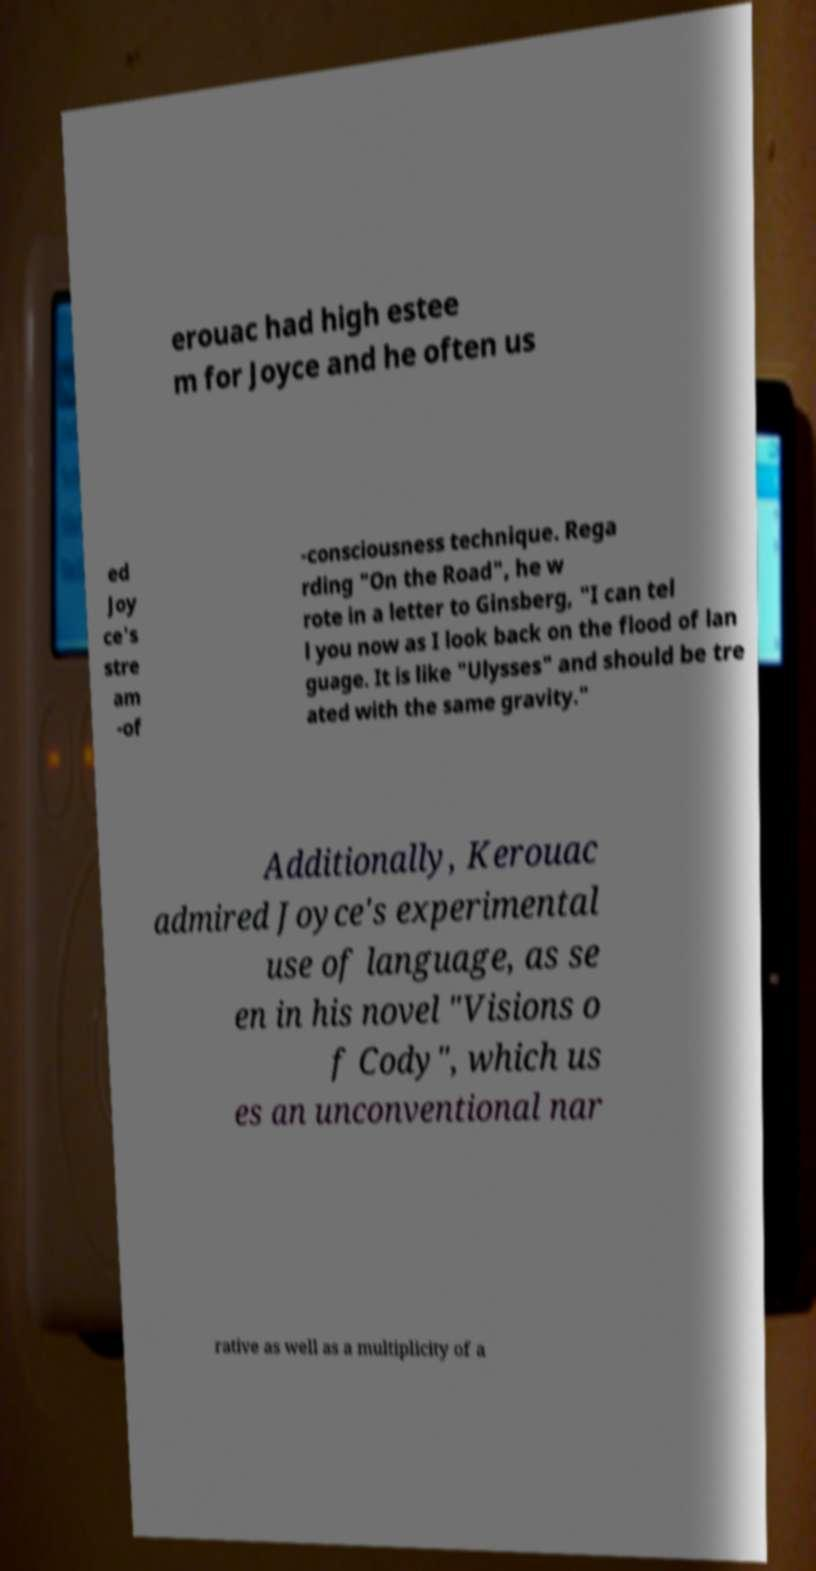Could you extract and type out the text from this image? erouac had high estee m for Joyce and he often us ed Joy ce's stre am -of -consciousness technique. Rega rding "On the Road", he w rote in a letter to Ginsberg, "I can tel l you now as I look back on the flood of lan guage. It is like "Ulysses" and should be tre ated with the same gravity." Additionally, Kerouac admired Joyce's experimental use of language, as se en in his novel "Visions o f Cody", which us es an unconventional nar rative as well as a multiplicity of a 